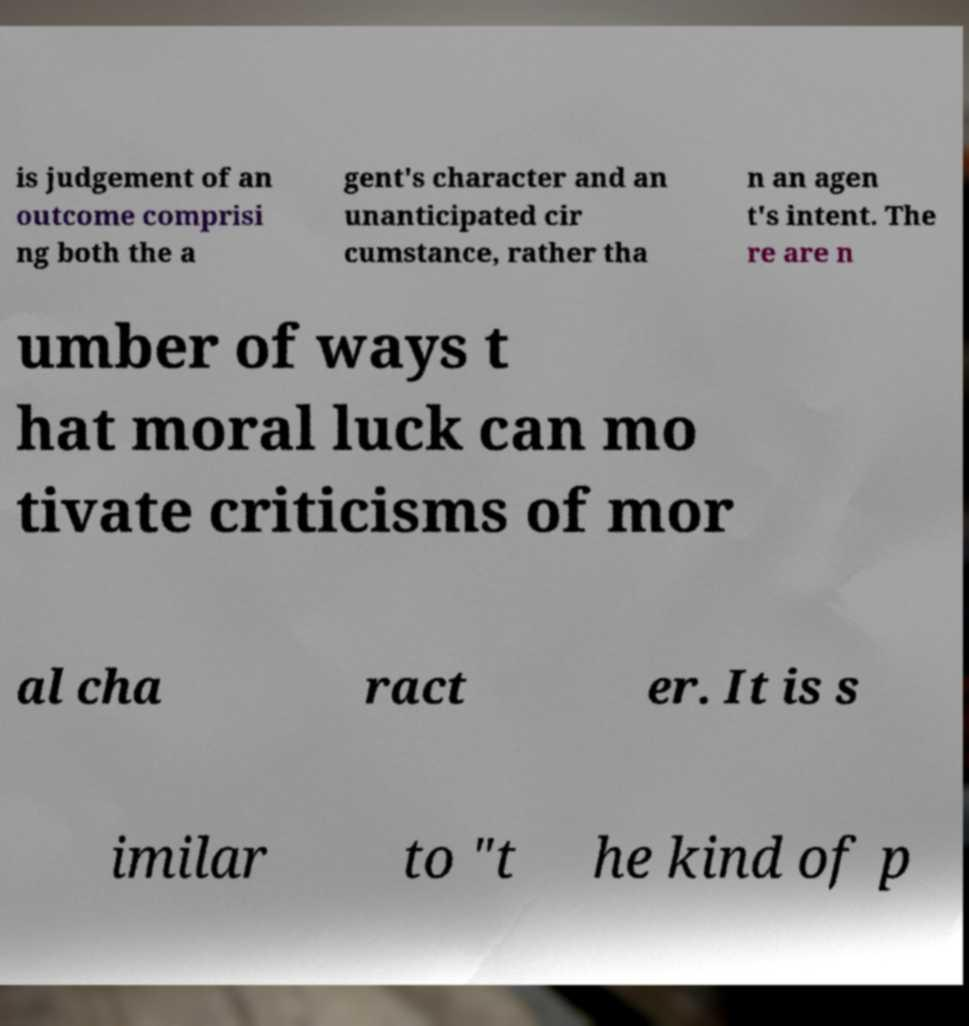I need the written content from this picture converted into text. Can you do that? is judgement of an outcome comprisi ng both the a gent's character and an unanticipated cir cumstance, rather tha n an agen t's intent. The re are n umber of ways t hat moral luck can mo tivate criticisms of mor al cha ract er. It is s imilar to "t he kind of p 